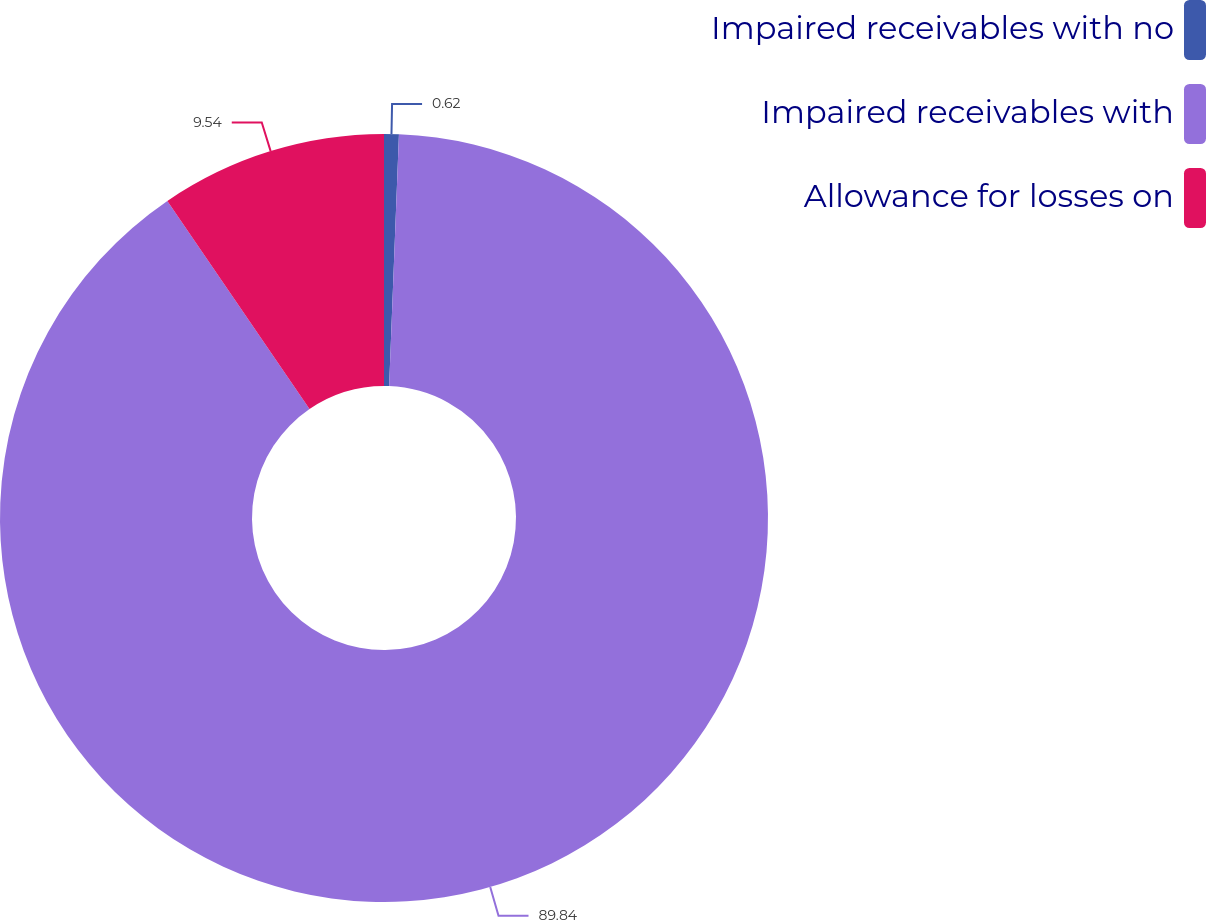Convert chart. <chart><loc_0><loc_0><loc_500><loc_500><pie_chart><fcel>Impaired receivables with no<fcel>Impaired receivables with<fcel>Allowance for losses on<nl><fcel>0.62%<fcel>89.83%<fcel>9.54%<nl></chart> 